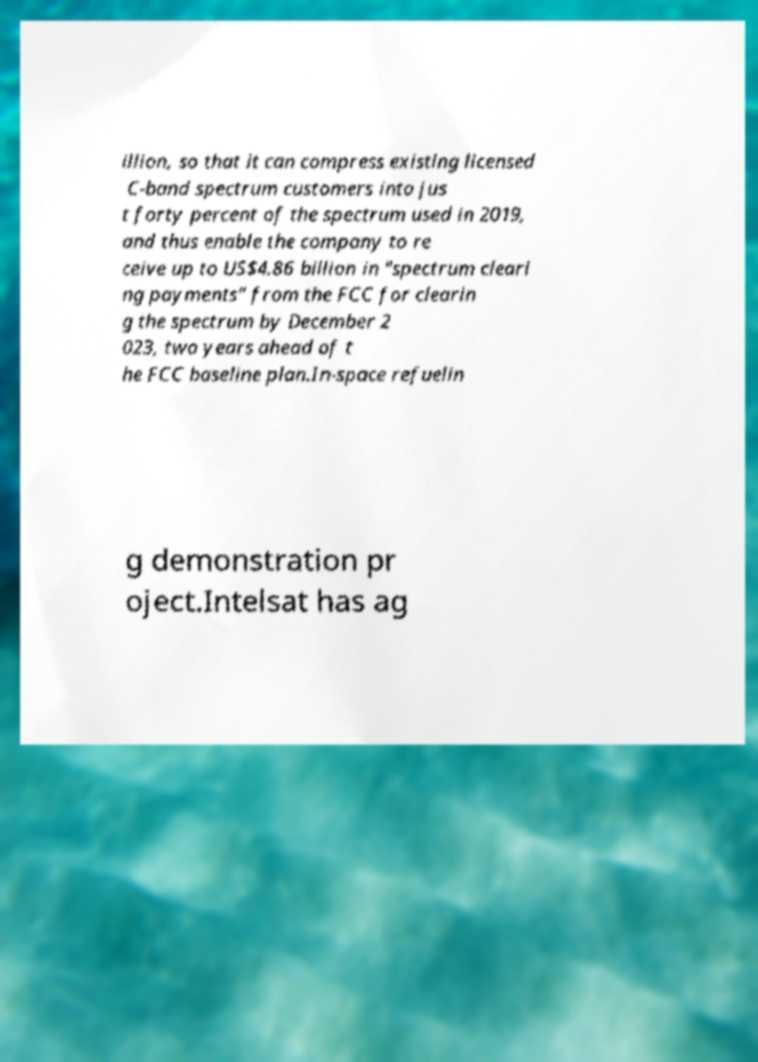Could you extract and type out the text from this image? illion, so that it can compress existing licensed C-band spectrum customers into jus t forty percent of the spectrum used in 2019, and thus enable the company to re ceive up to US$4.86 billion in "spectrum cleari ng payments" from the FCC for clearin g the spectrum by December 2 023, two years ahead of t he FCC baseline plan.In-space refuelin g demonstration pr oject.Intelsat has ag 